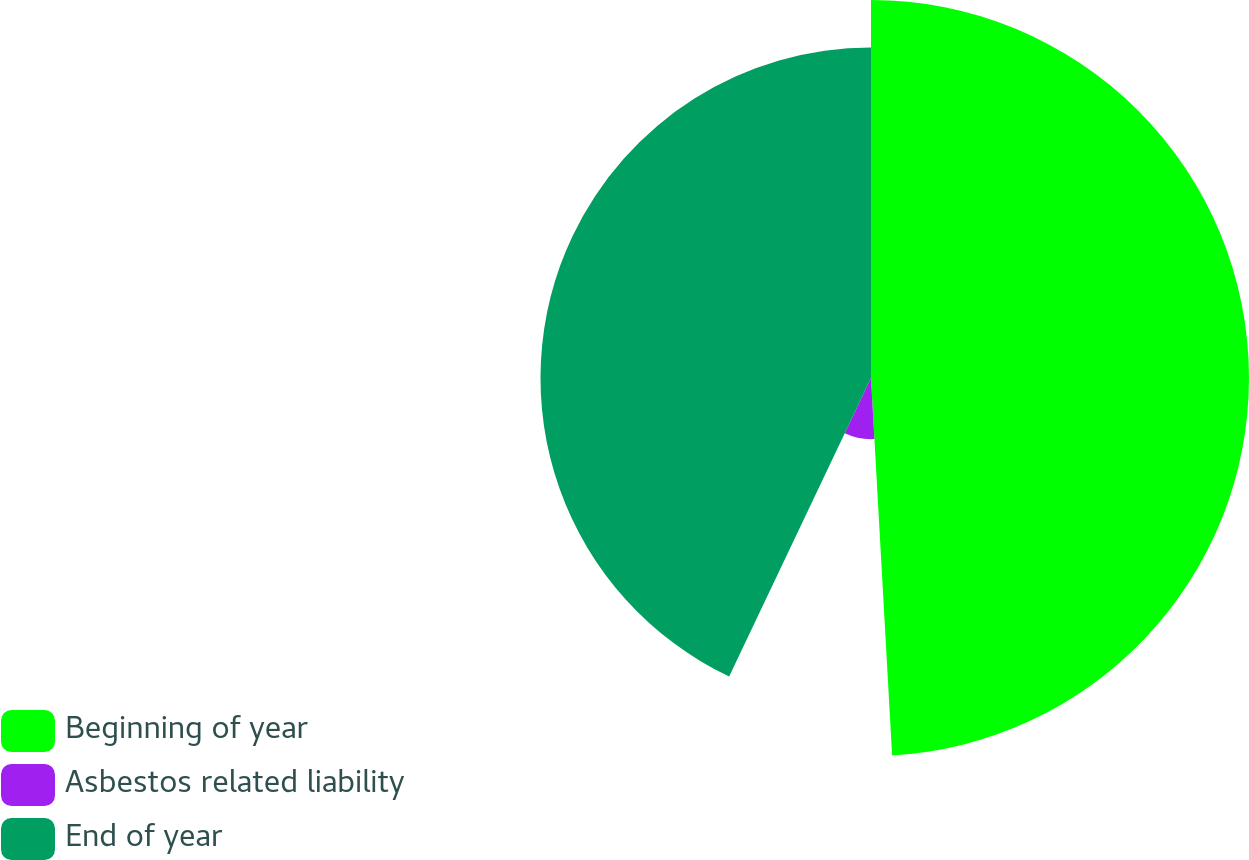Convert chart. <chart><loc_0><loc_0><loc_500><loc_500><pie_chart><fcel>Beginning of year<fcel>Asbestos related liability<fcel>End of year<nl><fcel>49.11%<fcel>7.95%<fcel>42.94%<nl></chart> 